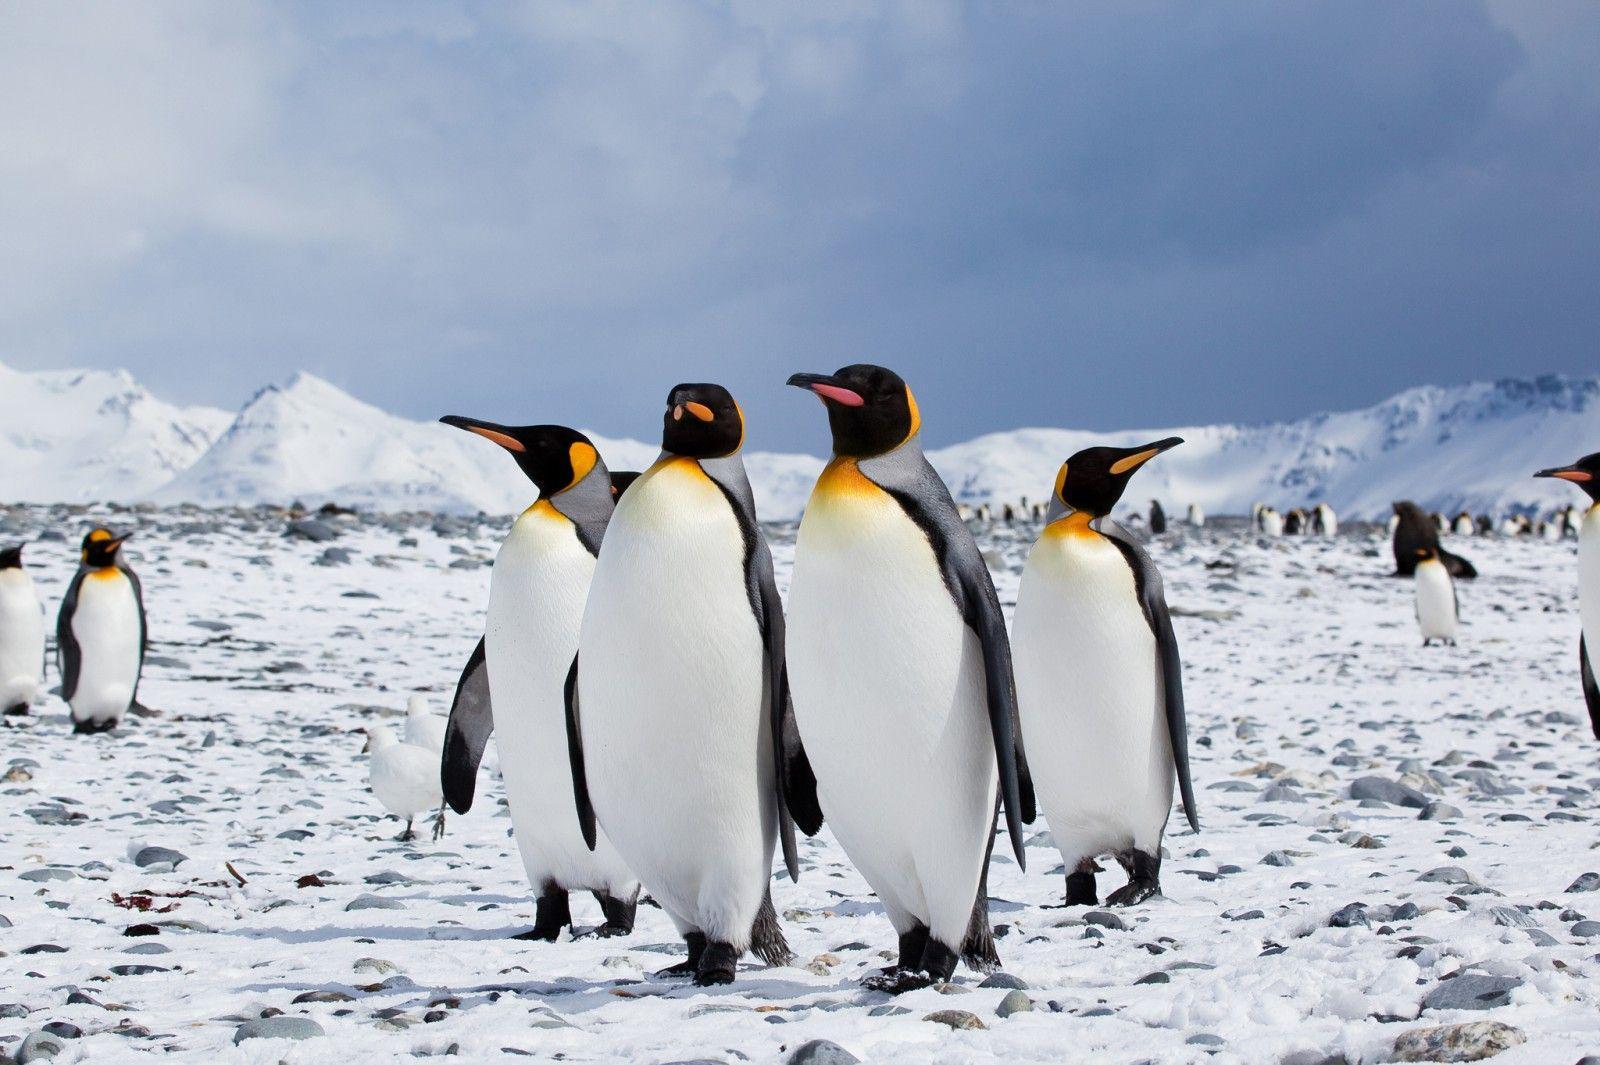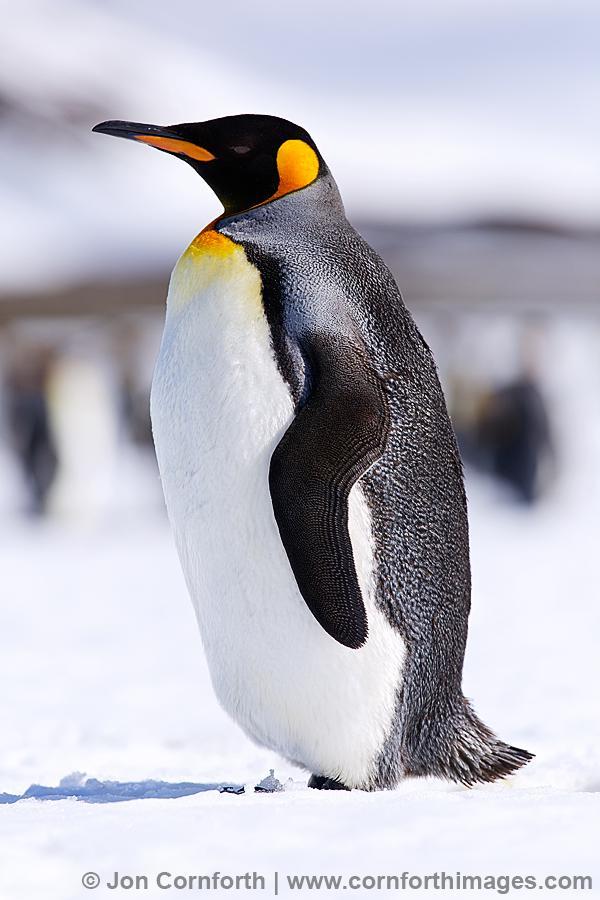The first image is the image on the left, the second image is the image on the right. For the images shown, is this caption "In one of the images, all penguins are facing right." true? Answer yes or no. No. The first image is the image on the left, the second image is the image on the right. For the images displayed, is the sentence "One image shows a single adult penguin, standing on snow and facing left." factually correct? Answer yes or no. Yes. 